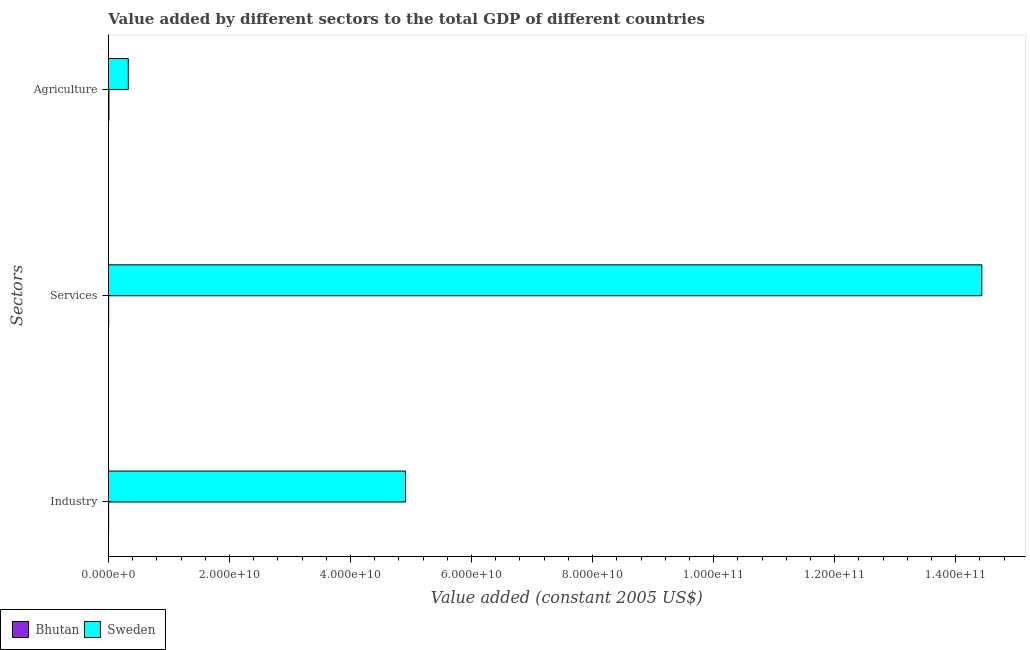How many different coloured bars are there?
Your answer should be compact. 2. Are the number of bars per tick equal to the number of legend labels?
Provide a short and direct response. Yes. Are the number of bars on each tick of the Y-axis equal?
Provide a short and direct response. Yes. What is the label of the 1st group of bars from the top?
Give a very brief answer. Agriculture. What is the value added by industrial sector in Bhutan?
Make the answer very short. 3.24e+07. Across all countries, what is the maximum value added by agricultural sector?
Provide a short and direct response. 3.28e+09. Across all countries, what is the minimum value added by agricultural sector?
Provide a succinct answer. 8.71e+07. In which country was the value added by services minimum?
Give a very brief answer. Bhutan. What is the total value added by agricultural sector in the graph?
Make the answer very short. 3.37e+09. What is the difference between the value added by agricultural sector in Bhutan and that in Sweden?
Provide a succinct answer. -3.19e+09. What is the difference between the value added by services in Bhutan and the value added by industrial sector in Sweden?
Provide a short and direct response. -4.90e+1. What is the average value added by agricultural sector per country?
Offer a very short reply. 1.68e+09. What is the difference between the value added by agricultural sector and value added by industrial sector in Bhutan?
Provide a succinct answer. 5.47e+07. In how many countries, is the value added by agricultural sector greater than 80000000000 US$?
Your response must be concise. 0. What is the ratio of the value added by agricultural sector in Bhutan to that in Sweden?
Your answer should be compact. 0.03. Is the difference between the value added by agricultural sector in Bhutan and Sweden greater than the difference between the value added by industrial sector in Bhutan and Sweden?
Keep it short and to the point. Yes. What is the difference between the highest and the second highest value added by services?
Provide a succinct answer. 1.44e+11. What is the difference between the highest and the lowest value added by industrial sector?
Offer a terse response. 4.91e+1. In how many countries, is the value added by agricultural sector greater than the average value added by agricultural sector taken over all countries?
Provide a succinct answer. 1. What does the 2nd bar from the top in Industry represents?
Your answer should be very brief. Bhutan. What does the 1st bar from the bottom in Services represents?
Provide a short and direct response. Bhutan. How many bars are there?
Provide a succinct answer. 6. How many countries are there in the graph?
Give a very brief answer. 2. What is the difference between two consecutive major ticks on the X-axis?
Provide a succinct answer. 2.00e+1. Are the values on the major ticks of X-axis written in scientific E-notation?
Your answer should be compact. Yes. How many legend labels are there?
Make the answer very short. 2. How are the legend labels stacked?
Your answer should be very brief. Horizontal. What is the title of the graph?
Give a very brief answer. Value added by different sectors to the total GDP of different countries. Does "Finland" appear as one of the legend labels in the graph?
Give a very brief answer. No. What is the label or title of the X-axis?
Offer a terse response. Value added (constant 2005 US$). What is the label or title of the Y-axis?
Provide a short and direct response. Sectors. What is the Value added (constant 2005 US$) in Bhutan in Industry?
Give a very brief answer. 3.24e+07. What is the Value added (constant 2005 US$) in Sweden in Industry?
Offer a very short reply. 4.91e+1. What is the Value added (constant 2005 US$) of Bhutan in Services?
Ensure brevity in your answer.  3.91e+07. What is the Value added (constant 2005 US$) of Sweden in Services?
Provide a succinct answer. 1.44e+11. What is the Value added (constant 2005 US$) in Bhutan in Agriculture?
Keep it short and to the point. 8.71e+07. What is the Value added (constant 2005 US$) of Sweden in Agriculture?
Give a very brief answer. 3.28e+09. Across all Sectors, what is the maximum Value added (constant 2005 US$) of Bhutan?
Provide a succinct answer. 8.71e+07. Across all Sectors, what is the maximum Value added (constant 2005 US$) of Sweden?
Your response must be concise. 1.44e+11. Across all Sectors, what is the minimum Value added (constant 2005 US$) in Bhutan?
Ensure brevity in your answer.  3.24e+07. Across all Sectors, what is the minimum Value added (constant 2005 US$) of Sweden?
Offer a terse response. 3.28e+09. What is the total Value added (constant 2005 US$) of Bhutan in the graph?
Offer a terse response. 1.59e+08. What is the total Value added (constant 2005 US$) in Sweden in the graph?
Make the answer very short. 1.97e+11. What is the difference between the Value added (constant 2005 US$) in Bhutan in Industry and that in Services?
Offer a terse response. -6.70e+06. What is the difference between the Value added (constant 2005 US$) of Sweden in Industry and that in Services?
Ensure brevity in your answer.  -9.52e+1. What is the difference between the Value added (constant 2005 US$) in Bhutan in Industry and that in Agriculture?
Your response must be concise. -5.47e+07. What is the difference between the Value added (constant 2005 US$) of Sweden in Industry and that in Agriculture?
Provide a succinct answer. 4.58e+1. What is the difference between the Value added (constant 2005 US$) of Bhutan in Services and that in Agriculture?
Your answer should be very brief. -4.80e+07. What is the difference between the Value added (constant 2005 US$) in Sweden in Services and that in Agriculture?
Your response must be concise. 1.41e+11. What is the difference between the Value added (constant 2005 US$) in Bhutan in Industry and the Value added (constant 2005 US$) in Sweden in Services?
Give a very brief answer. -1.44e+11. What is the difference between the Value added (constant 2005 US$) in Bhutan in Industry and the Value added (constant 2005 US$) in Sweden in Agriculture?
Provide a succinct answer. -3.25e+09. What is the difference between the Value added (constant 2005 US$) in Bhutan in Services and the Value added (constant 2005 US$) in Sweden in Agriculture?
Offer a very short reply. -3.24e+09. What is the average Value added (constant 2005 US$) of Bhutan per Sectors?
Give a very brief answer. 5.29e+07. What is the average Value added (constant 2005 US$) of Sweden per Sectors?
Your response must be concise. 6.56e+1. What is the difference between the Value added (constant 2005 US$) in Bhutan and Value added (constant 2005 US$) in Sweden in Industry?
Offer a terse response. -4.91e+1. What is the difference between the Value added (constant 2005 US$) in Bhutan and Value added (constant 2005 US$) in Sweden in Services?
Provide a succinct answer. -1.44e+11. What is the difference between the Value added (constant 2005 US$) in Bhutan and Value added (constant 2005 US$) in Sweden in Agriculture?
Offer a very short reply. -3.19e+09. What is the ratio of the Value added (constant 2005 US$) in Bhutan in Industry to that in Services?
Ensure brevity in your answer.  0.83. What is the ratio of the Value added (constant 2005 US$) of Sweden in Industry to that in Services?
Keep it short and to the point. 0.34. What is the ratio of the Value added (constant 2005 US$) in Bhutan in Industry to that in Agriculture?
Your response must be concise. 0.37. What is the ratio of the Value added (constant 2005 US$) in Sweden in Industry to that in Agriculture?
Your response must be concise. 14.96. What is the ratio of the Value added (constant 2005 US$) of Bhutan in Services to that in Agriculture?
Your answer should be compact. 0.45. What is the ratio of the Value added (constant 2005 US$) in Sweden in Services to that in Agriculture?
Provide a short and direct response. 43.98. What is the difference between the highest and the second highest Value added (constant 2005 US$) in Bhutan?
Your answer should be compact. 4.80e+07. What is the difference between the highest and the second highest Value added (constant 2005 US$) of Sweden?
Provide a succinct answer. 9.52e+1. What is the difference between the highest and the lowest Value added (constant 2005 US$) of Bhutan?
Your answer should be compact. 5.47e+07. What is the difference between the highest and the lowest Value added (constant 2005 US$) in Sweden?
Your answer should be very brief. 1.41e+11. 